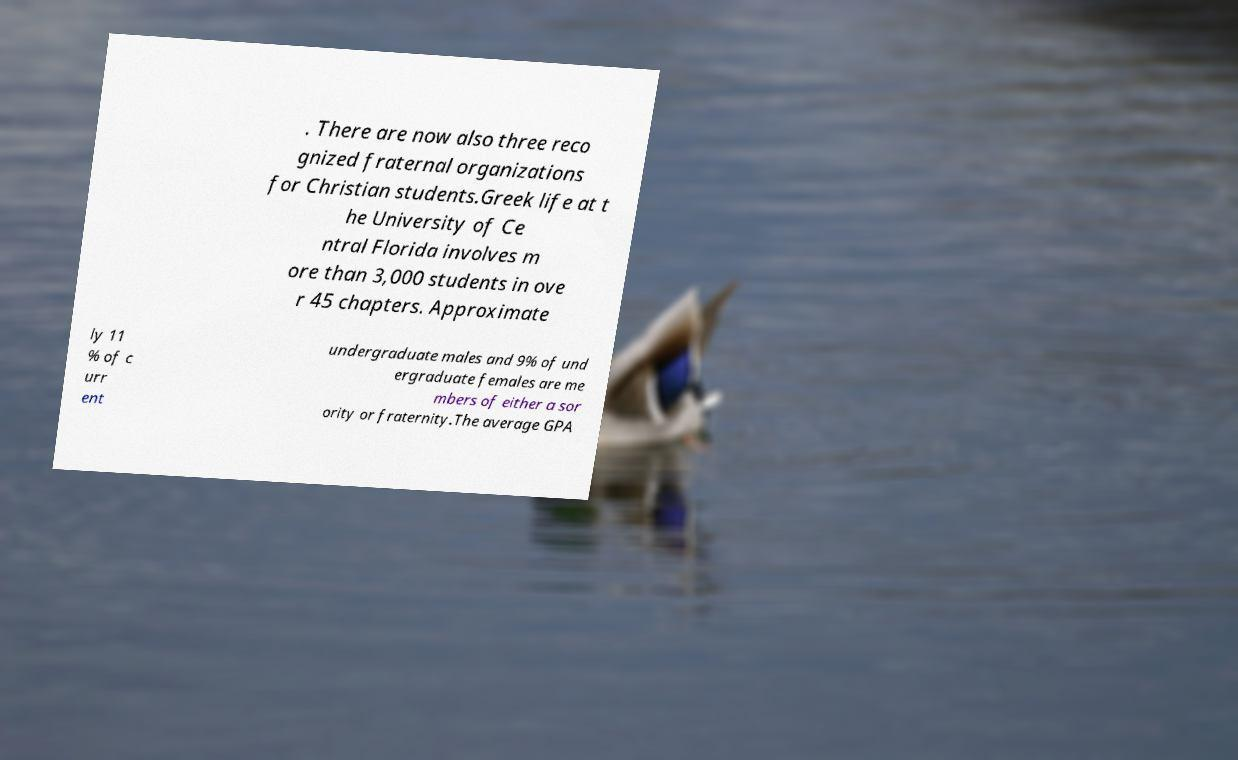There's text embedded in this image that I need extracted. Can you transcribe it verbatim? . There are now also three reco gnized fraternal organizations for Christian students.Greek life at t he University of Ce ntral Florida involves m ore than 3,000 students in ove r 45 chapters. Approximate ly 11 % of c urr ent undergraduate males and 9% of und ergraduate females are me mbers of either a sor ority or fraternity.The average GPA 